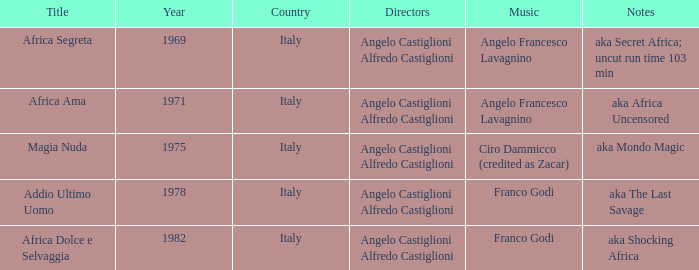Can you identify the notes used in the aka africa uncensored music? Angelo Francesco Lavagnino. 